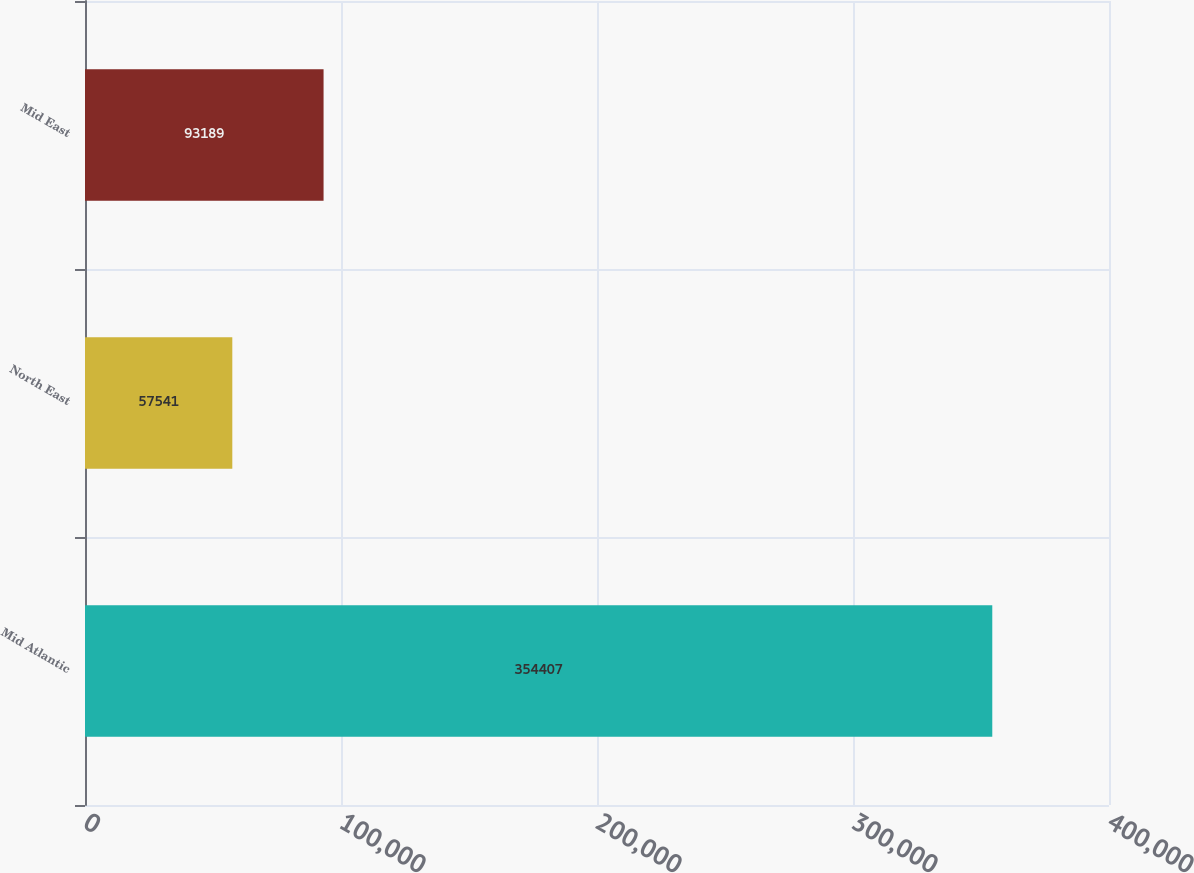<chart> <loc_0><loc_0><loc_500><loc_500><bar_chart><fcel>Mid Atlantic<fcel>North East<fcel>Mid East<nl><fcel>354407<fcel>57541<fcel>93189<nl></chart> 